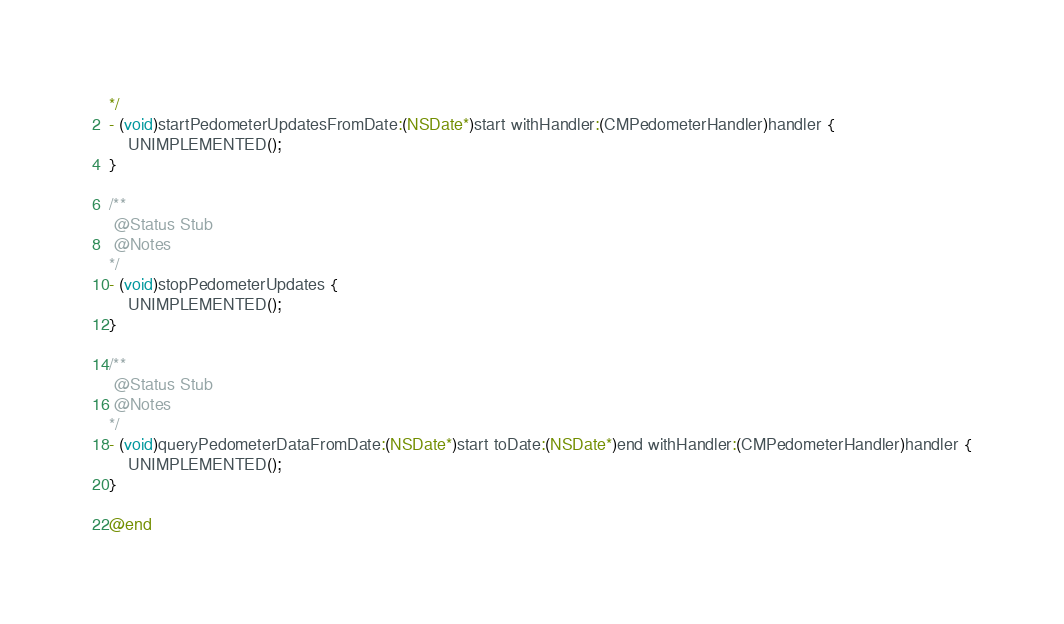<code> <loc_0><loc_0><loc_500><loc_500><_ObjectiveC_>*/
- (void)startPedometerUpdatesFromDate:(NSDate*)start withHandler:(CMPedometerHandler)handler {
    UNIMPLEMENTED();
}

/**
 @Status Stub
 @Notes
*/
- (void)stopPedometerUpdates {
    UNIMPLEMENTED();
}

/**
 @Status Stub
 @Notes
*/
- (void)queryPedometerDataFromDate:(NSDate*)start toDate:(NSDate*)end withHandler:(CMPedometerHandler)handler {
    UNIMPLEMENTED();
}

@end
</code> 